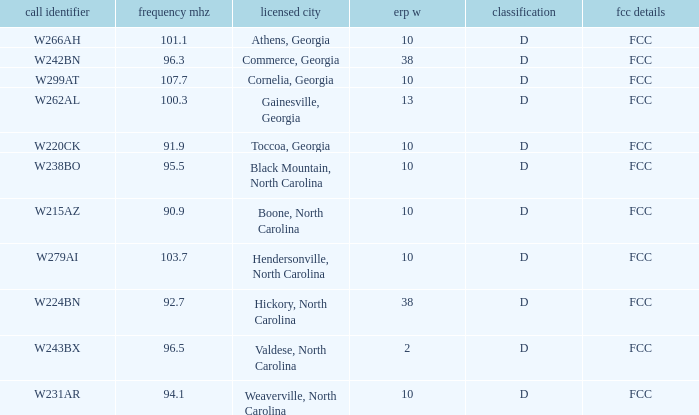What is the Frequency MHz for the station with a call sign of w224bn? 92.7. 